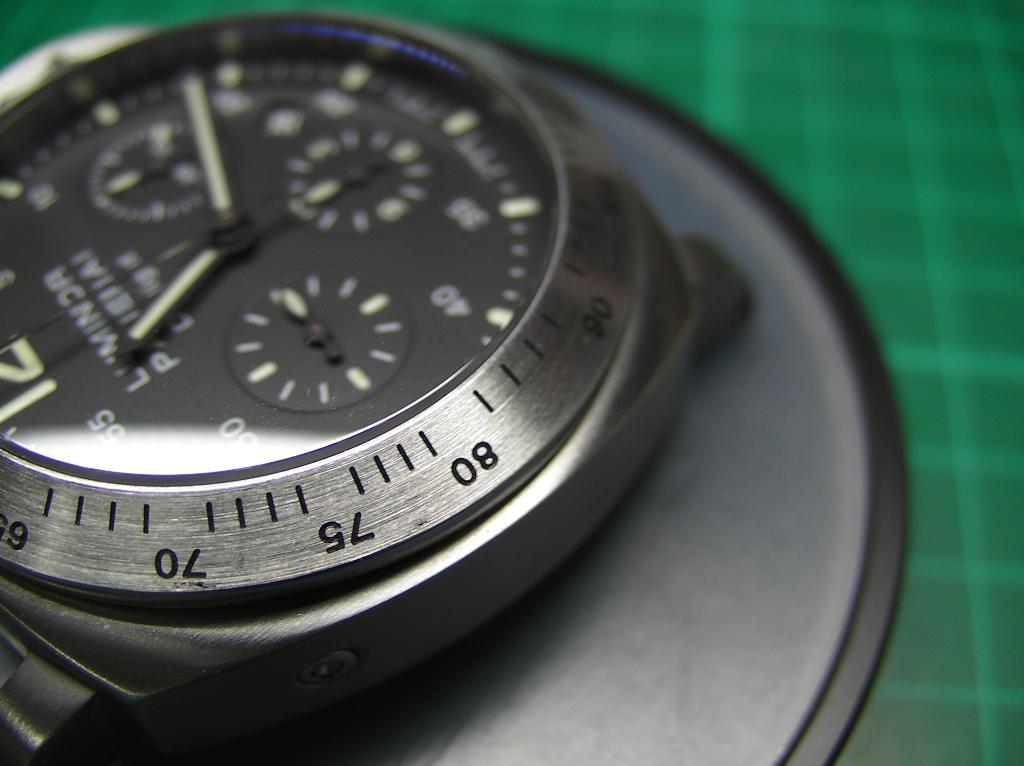What time is on the watch?
Keep it short and to the point. 11:19. What time does the watch read?
Provide a short and direct response. 11:19. 